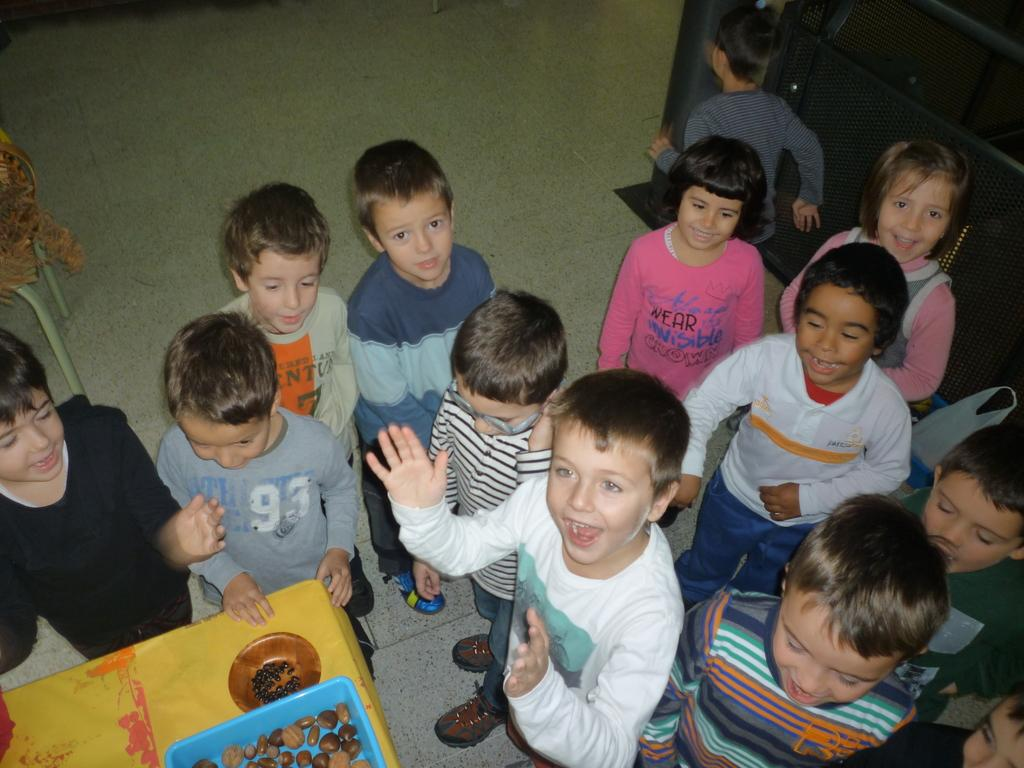What can be seen in the image involving young individuals? There are children standing in the image. What is located on the table in the image? There are objects on a table in the image. What type of advertisement can be seen near the children in the image? There is no advertisement present in the image; it only features children standing and objects on a table. 